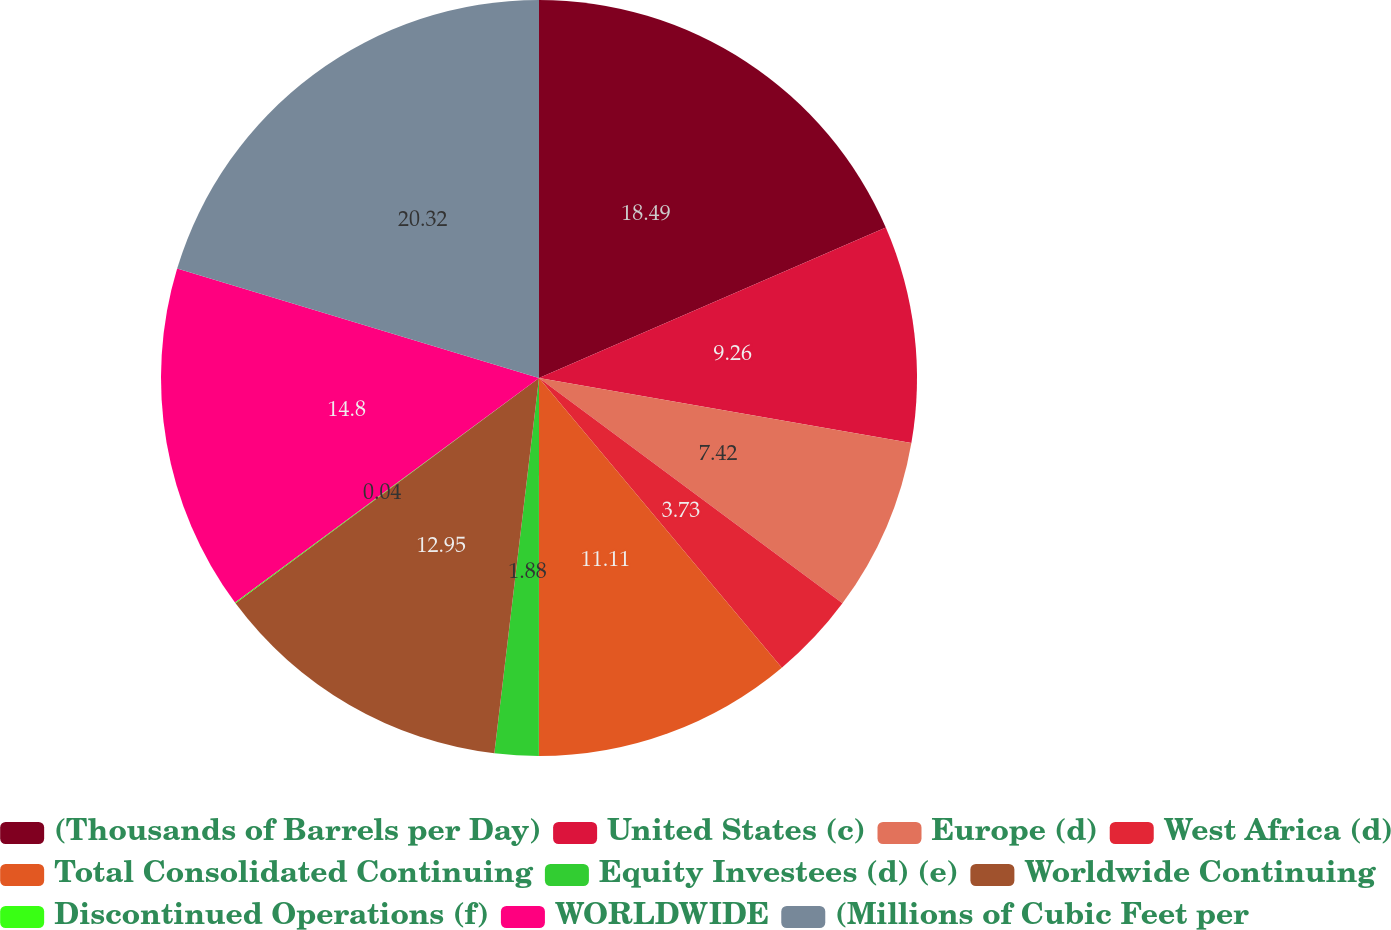<chart> <loc_0><loc_0><loc_500><loc_500><pie_chart><fcel>(Thousands of Barrels per Day)<fcel>United States (c)<fcel>Europe (d)<fcel>West Africa (d)<fcel>Total Consolidated Continuing<fcel>Equity Investees (d) (e)<fcel>Worldwide Continuing<fcel>Discontinued Operations (f)<fcel>WORLDWIDE<fcel>(Millions of Cubic Feet per<nl><fcel>18.49%<fcel>9.26%<fcel>7.42%<fcel>3.73%<fcel>11.11%<fcel>1.88%<fcel>12.95%<fcel>0.04%<fcel>14.8%<fcel>20.33%<nl></chart> 